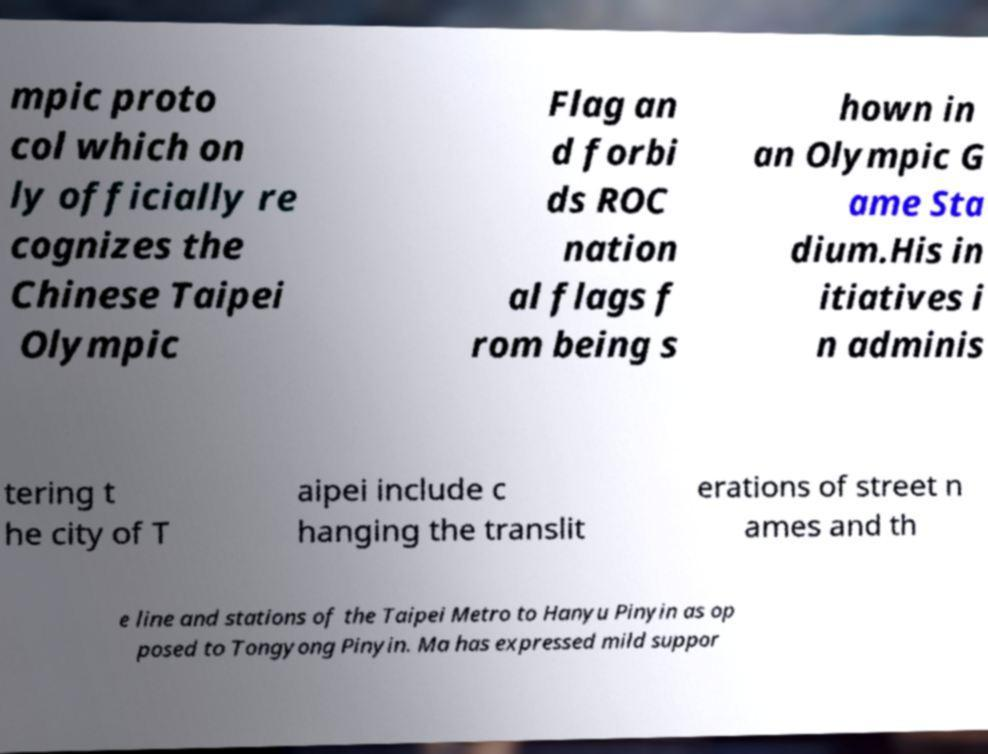Can you accurately transcribe the text from the provided image for me? mpic proto col which on ly officially re cognizes the Chinese Taipei Olympic Flag an d forbi ds ROC nation al flags f rom being s hown in an Olympic G ame Sta dium.His in itiatives i n adminis tering t he city of T aipei include c hanging the translit erations of street n ames and th e line and stations of the Taipei Metro to Hanyu Pinyin as op posed to Tongyong Pinyin. Ma has expressed mild suppor 